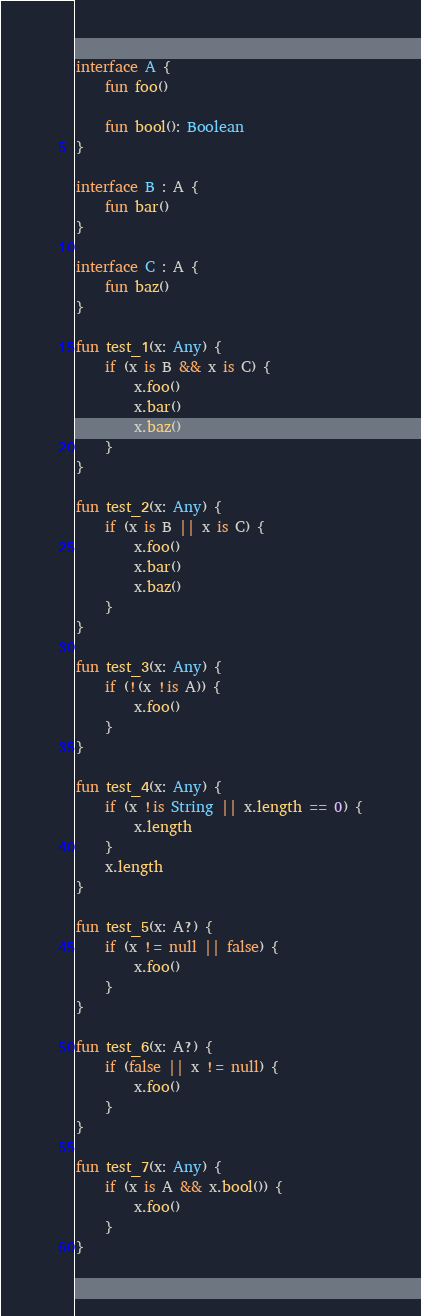Convert code to text. <code><loc_0><loc_0><loc_500><loc_500><_Kotlin_>interface A {
    fun foo()

    fun bool(): Boolean
}

interface B : A {
    fun bar()
}

interface C : A {
    fun baz()
}

fun test_1(x: Any) {
    if (x is B && x is C) {
        x.foo()
        x.bar()
        x.baz()
    }
}

fun test_2(x: Any) {
    if (x is B || x is C) {
        x.foo()
        x.bar()
        x.baz()
    }
}

fun test_3(x: Any) {
    if (!(x !is A)) {
        x.foo()
    }
}

fun test_4(x: Any) {
    if (x !is String || x.length == 0) {
        x.length
    }
    x.length
}

fun test_5(x: A?) {
    if (x != null || false) {
        x.foo()
    }
}

fun test_6(x: A?) {
    if (false || x != null) {
        x.foo()
    }
}

fun test_7(x: Any) {
    if (x is A && x.bool()) {
        x.foo()
    }
}</code> 